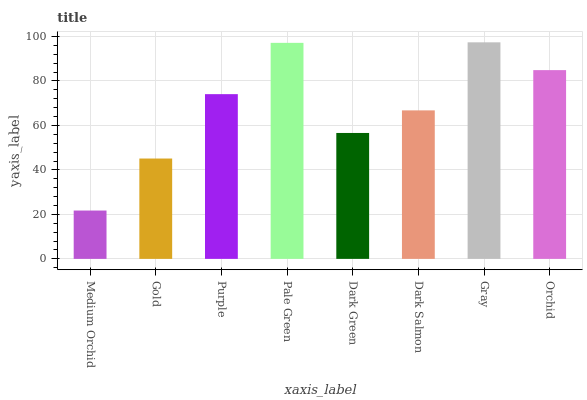Is Medium Orchid the minimum?
Answer yes or no. Yes. Is Gray the maximum?
Answer yes or no. Yes. Is Gold the minimum?
Answer yes or no. No. Is Gold the maximum?
Answer yes or no. No. Is Gold greater than Medium Orchid?
Answer yes or no. Yes. Is Medium Orchid less than Gold?
Answer yes or no. Yes. Is Medium Orchid greater than Gold?
Answer yes or no. No. Is Gold less than Medium Orchid?
Answer yes or no. No. Is Purple the high median?
Answer yes or no. Yes. Is Dark Salmon the low median?
Answer yes or no. Yes. Is Dark Green the high median?
Answer yes or no. No. Is Medium Orchid the low median?
Answer yes or no. No. 